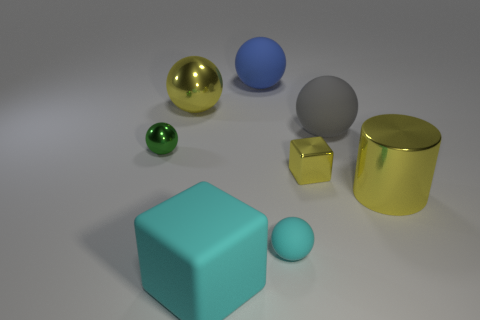Subtract 1 spheres. How many spheres are left? 4 Subtract all blue balls. How many balls are left? 4 Subtract all small rubber spheres. How many spheres are left? 4 Subtract all red cylinders. Subtract all blue spheres. How many cylinders are left? 1 Add 1 small cyan rubber cubes. How many objects exist? 9 Subtract all cylinders. How many objects are left? 7 Subtract all small yellow rubber objects. Subtract all rubber spheres. How many objects are left? 5 Add 4 yellow metal cubes. How many yellow metal cubes are left? 5 Add 4 large blue metallic balls. How many large blue metallic balls exist? 4 Subtract 0 green cylinders. How many objects are left? 8 